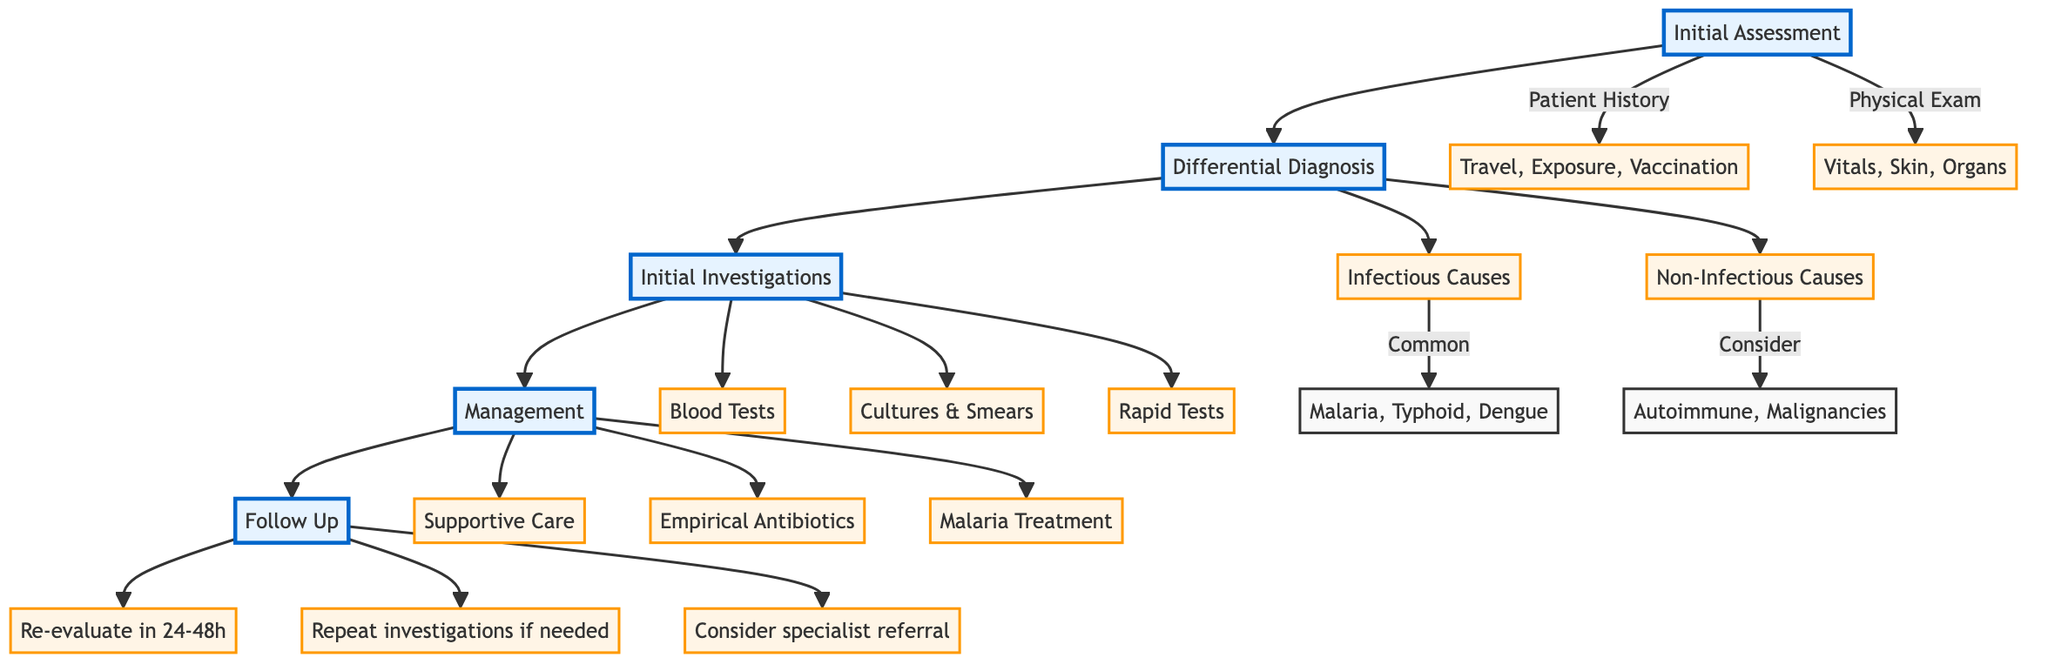What is the first step in the clinical pathway? The diagram shows that the first step in the clinical pathway is the "Initial Assessment." This is indicated as the first node connected to the subsequent nodes for "Differential Diagnosis."
Answer: Initial Assessment How many categories are in the Differential Diagnosis section? The diagram indicates that there are two main categories in the Differential Diagnosis section: "Infectious Causes" and "Non-Infectious Causes."
Answer: 2 What are the common infectious causes listed? The "Infectious Causes" node includes "Malaria," "Typhoid fever," and "Dengue fever" as common diseases. This information is directly taken from the node detailing the infectious causes.
Answer: Malaria, Typhoid fever, Dengue fever What type of care is included under Management? The "Management" section lists "Supportive Care," which comprises "Antipyretics," "Hydration," and "Pain management." Therefore, these types of care can be extracted from the diagram.
Answer: Supportive Care Which investigations are recommended in the Initial Investigations? The Initial Investigations node lists procedures like "Blood smear for malaria," "Complete blood count (CBC)," and "Liver function tests (LFTs)." This information is extracted directly from the Initial Investigations node.
Answer: Blood smear for malaria, Complete blood count, Liver function tests What action follows the Management section? The diagram outlines that the next action after Management is "Follow Up," indicating a continued process after treatment initiation.
Answer: Follow Up How often should patients be re-evaluated after initial management? According to the Follow Up node, patients should be re-evaluated in "24-48 hours," which specifies the timeframe for reassessment.
Answer: 24-48 hours What are the two categories under Initial Assessment? The Initial Assessment includes two categories: "Patient History" and "Physical Exam," as detailed in the diagram under this section.
Answer: Patient History, Physical Exam What is the focus of the Non-Infectious Causes? The Non-Infectious Causes node specifies conditions such as "Autoimmune diseases," "Malignancies," and "Heat stroke," highlighting potential non-infectious illness considerations.
Answer: Autoimmune diseases, Malignancies, Heat stroke 